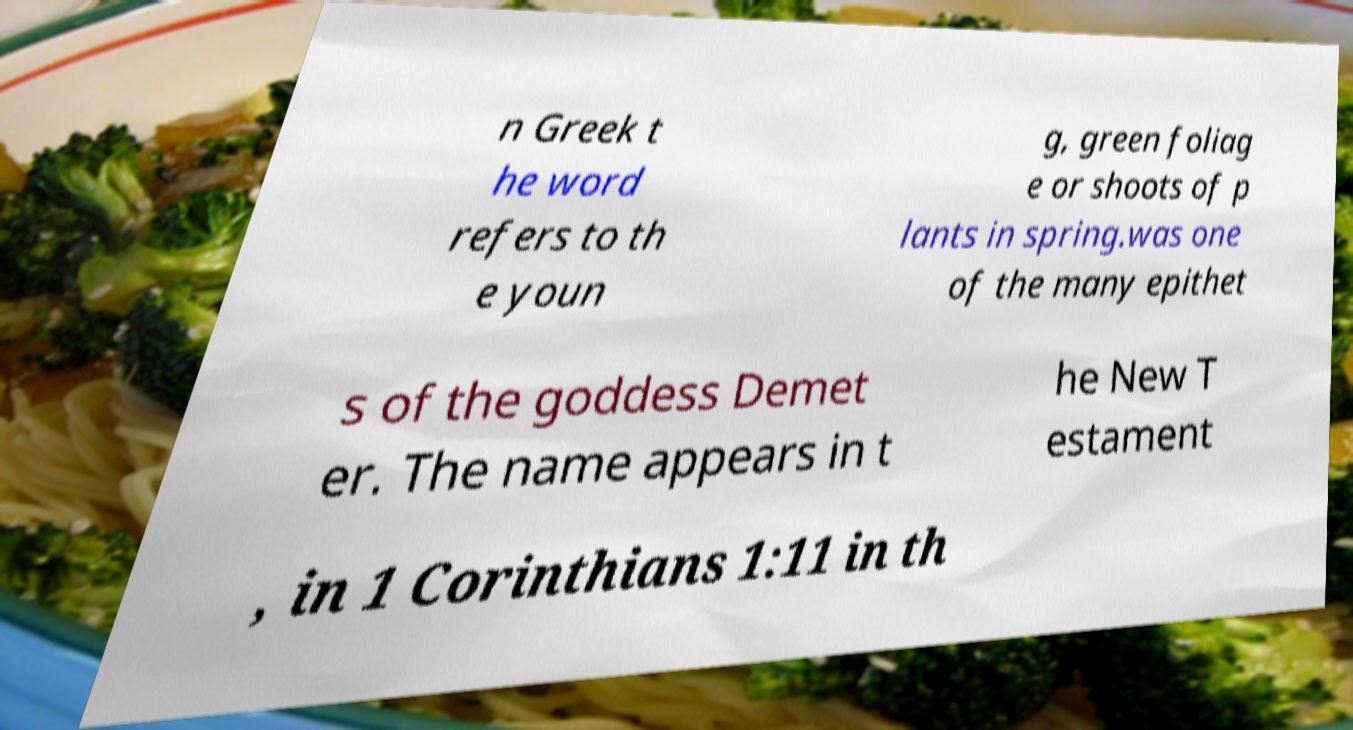Please read and relay the text visible in this image. What does it say? n Greek t he word refers to th e youn g, green foliag e or shoots of p lants in spring.was one of the many epithet s of the goddess Demet er. The name appears in t he New T estament , in 1 Corinthians 1:11 in th 